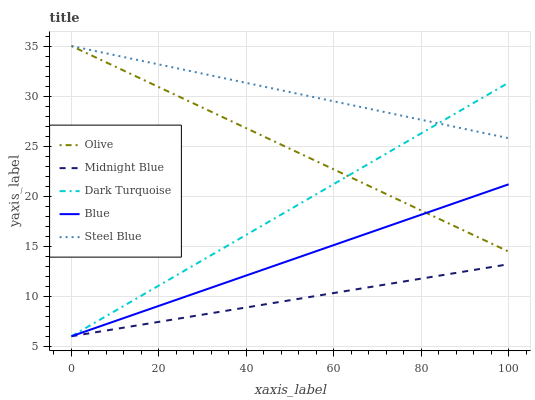Does Dark Turquoise have the minimum area under the curve?
Answer yes or no. No. Does Dark Turquoise have the maximum area under the curve?
Answer yes or no. No. Is Dark Turquoise the smoothest?
Answer yes or no. No. Is Dark Turquoise the roughest?
Answer yes or no. No. Does Steel Blue have the lowest value?
Answer yes or no. No. Does Dark Turquoise have the highest value?
Answer yes or no. No. Is Midnight Blue less than Steel Blue?
Answer yes or no. Yes. Is Steel Blue greater than Blue?
Answer yes or no. Yes. Does Midnight Blue intersect Steel Blue?
Answer yes or no. No. 